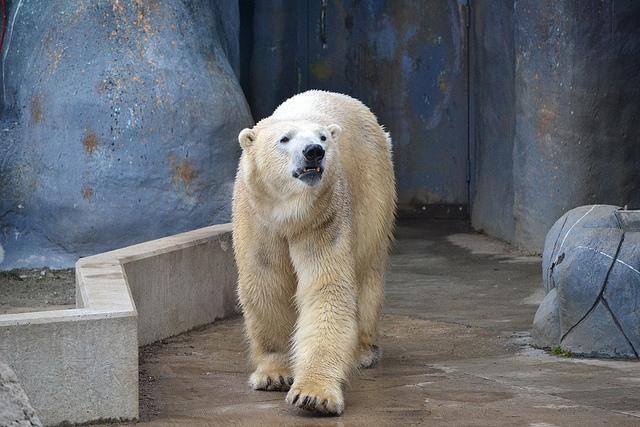How many bears are there?
Give a very brief answer. 1. 